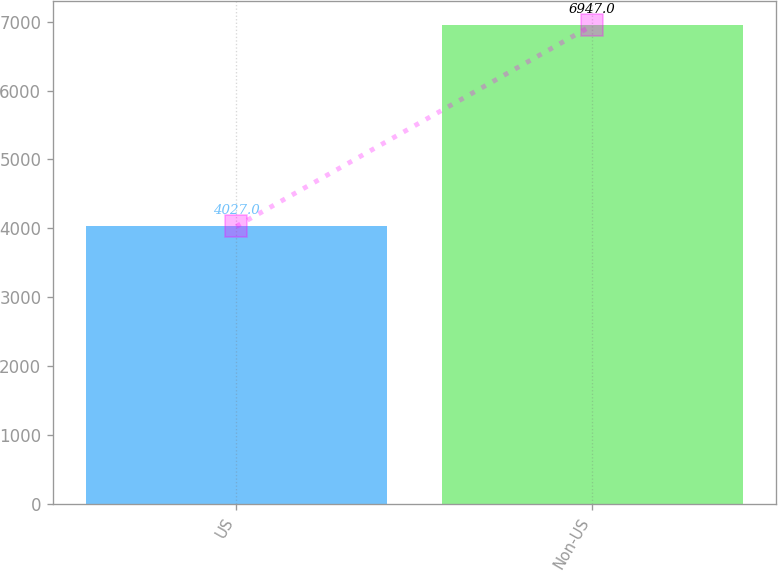Convert chart to OTSL. <chart><loc_0><loc_0><loc_500><loc_500><bar_chart><fcel>US<fcel>Non-US<nl><fcel>4027<fcel>6947<nl></chart> 